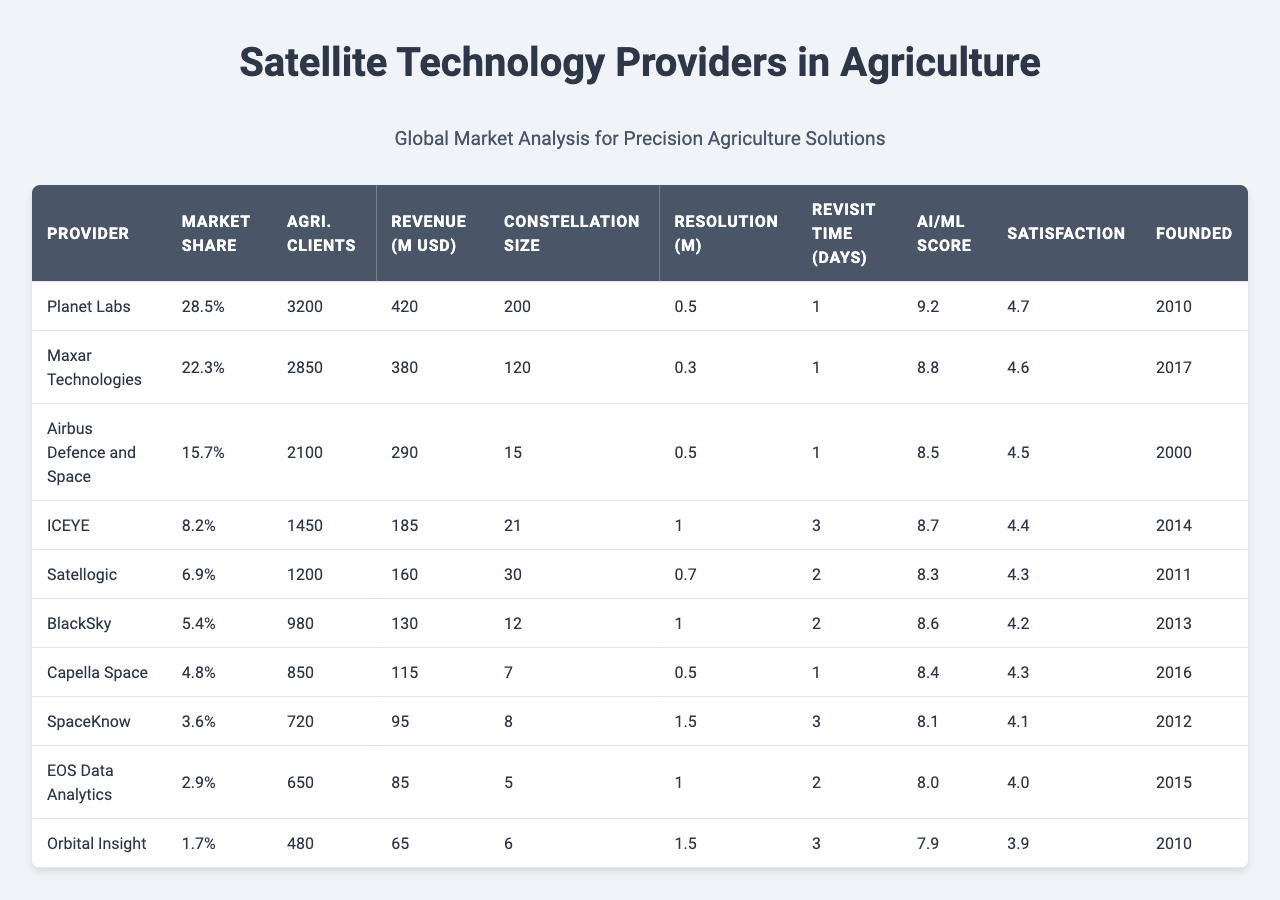What is the market share of Planet Labs? The market share is explicitly listed in the table under the "Market Share" column for Planet Labs, which is 28.5%.
Answer: 28.5% Which company has the highest number of agricultural clients? By reviewing the "Agri. Clients" column, we see that Planet Labs has the highest number at 3200 clients.
Answer: Planet Labs What is the combined revenue of the top three satellite technology providers? The revenues for the top three providers are 420, 380, and 290 million USD. Adding these together gives 420 + 380 + 290 = 1090 million USD.
Answer: 1090 million USD Is the AI/ML Integration Score of ICEYE higher than that of SatelLogic? The scores can be compared directly from the table; ICEYE has a score of 8.7 and SatelLogic has 8.3, so ICEYE's score is higher.
Answer: Yes What is the average customer satisfaction score of the bottom five providers? The scores for the bottom five providers are 4.2, 4.3, 4.1, 4.0, and 3.9. Summing them gives 4.2 + 4.3 + 4.1 + 4.0 + 3.9 = 20.5, and dividing by 5 results in an average of 20.5 / 5 = 4.1.
Answer: 4.1 Which company has the lowest image resolution, and what is that resolution? The "Resolution (m)" column indicates that Orbital Insight and BlackSky both have the lowest resolution of 1.5 meters.
Answer: Orbital Insight and BlackSky, 1.5 meters How many companies have a constellation size larger than 100? By checking the "Constellation Size" column, only Planet Labs (200) and Maxar Technologies (120) exceed 100, making a total of two companies.
Answer: 2 What is the company with the best AI/ML Integration Score and what is that score? The highest score in the "AI/ML Score" column is 9.2, associated with Planet Labs.
Answer: Planet Labs, 9.2 If all companies' agricultural clients were added together, what would this total be? Adding all values from the "Agri. Clients" column: 3200 + 2850 + 2100 + 1450 + 1200 + 980 + 850 + 720 + 650 + 480 = 15680.
Answer: 15680 Does any company have a revenue of less than 100 million USD? A review of the "Revenue (M USD)" column shows that the lowest figure is 65 million USD for Orbital Insight, indicating that yes, there are companies under 100 million revenue.
Answer: Yes 